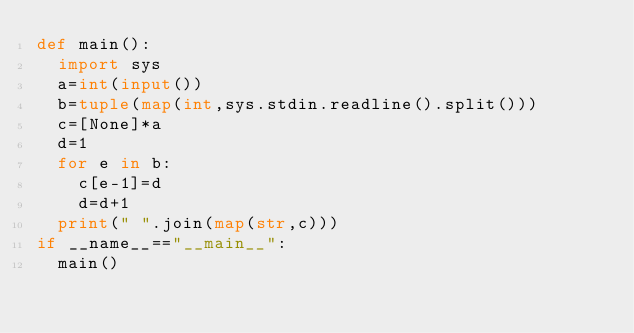Convert code to text. <code><loc_0><loc_0><loc_500><loc_500><_Python_>def main():
  import sys
  a=int(input())
  b=tuple(map(int,sys.stdin.readline().split()))
  c=[None]*a
  d=1
  for e in b:
    c[e-1]=d
    d=d+1
  print(" ".join(map(str,c)))
if __name__=="__main__":
  main()</code> 